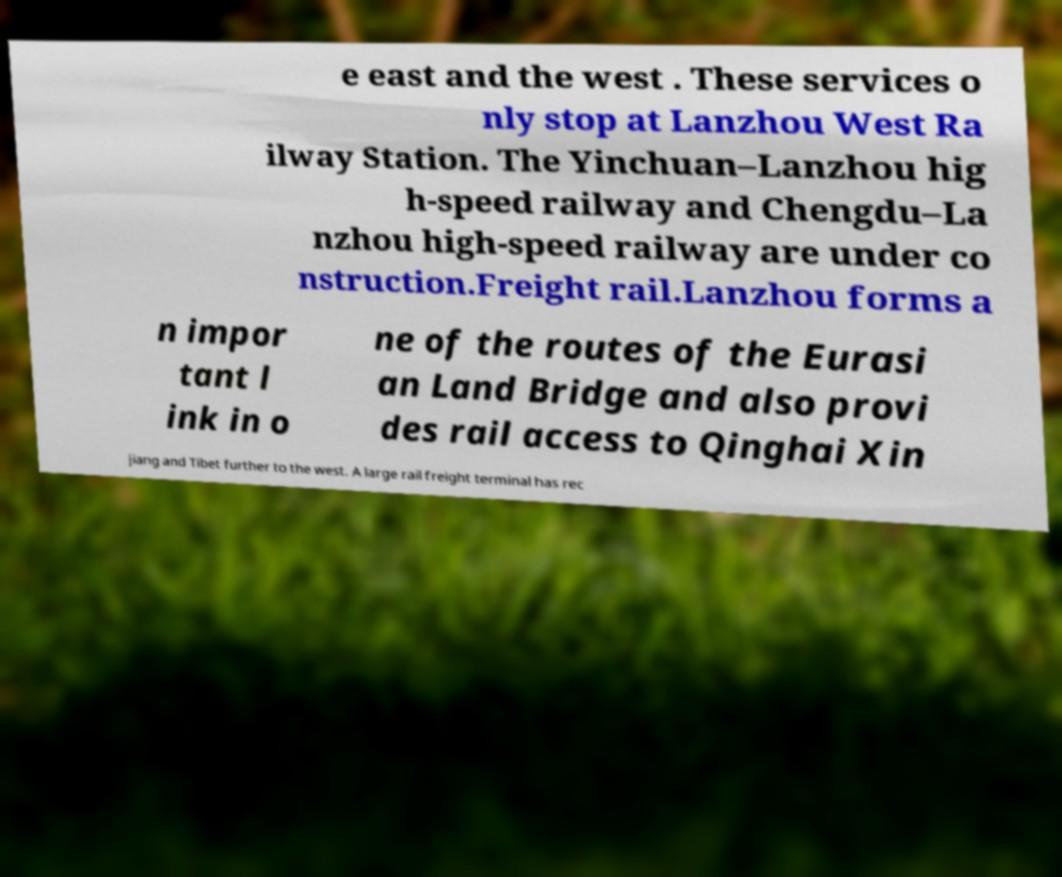There's text embedded in this image that I need extracted. Can you transcribe it verbatim? e east and the west . These services o nly stop at Lanzhou West Ra ilway Station. The Yinchuan–Lanzhou hig h-speed railway and Chengdu–La nzhou high-speed railway are under co nstruction.Freight rail.Lanzhou forms a n impor tant l ink in o ne of the routes of the Eurasi an Land Bridge and also provi des rail access to Qinghai Xin jiang and Tibet further to the west. A large rail freight terminal has rec 